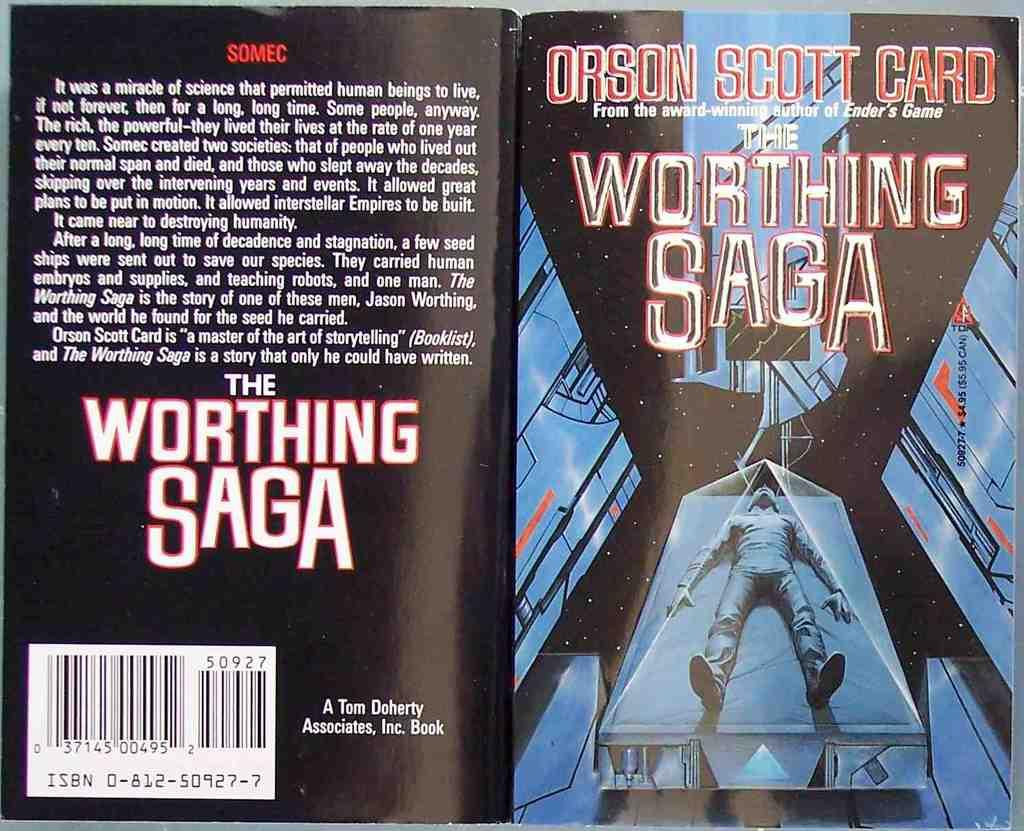<image>
Provide a brief description of the given image. An Orson Scott Card paperback is called The Worthing Saga. 